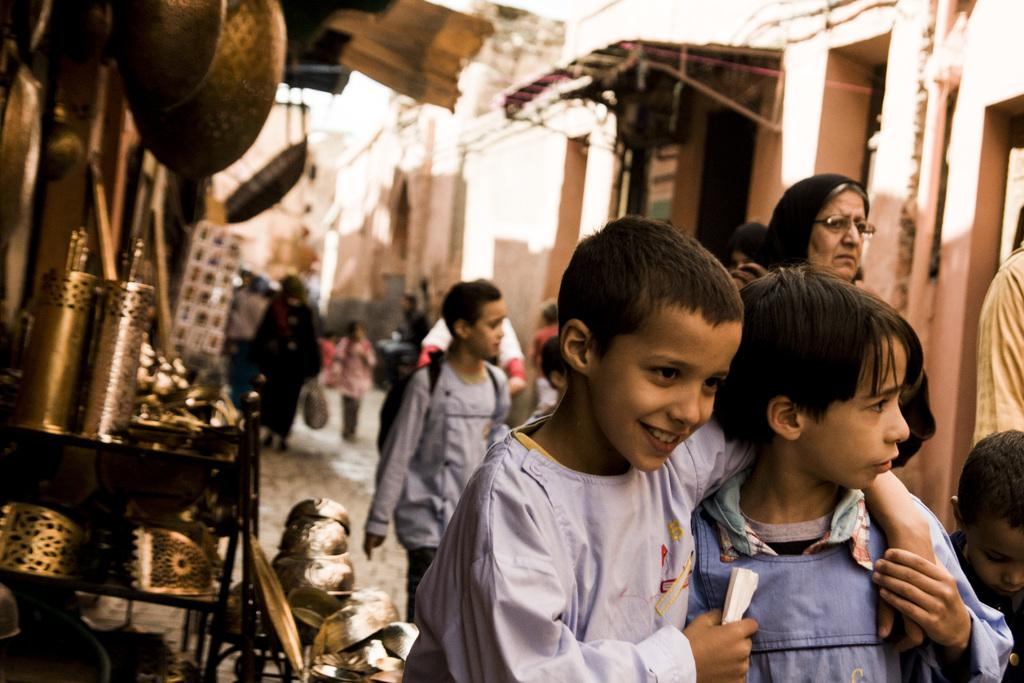What are the people in the image doing? The people in the image are walking on the road. What objects related to eating are present in the image? Cutlery and crockery are placed in a stand. What type of structures can be seen in the image? There are buildings visible in the image. What part of the natural environment is visible in the image? The sky is visible in the image. What type of yarn is being used to decorate the sofa in the image? There is no sofa or yarn present in the image. 